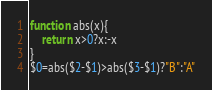Convert code to text. <code><loc_0><loc_0><loc_500><loc_500><_Awk_>function abs(x){
	return x>0?x:-x
}
$0=abs($2-$1)>abs($3-$1)?"B":"A"</code> 